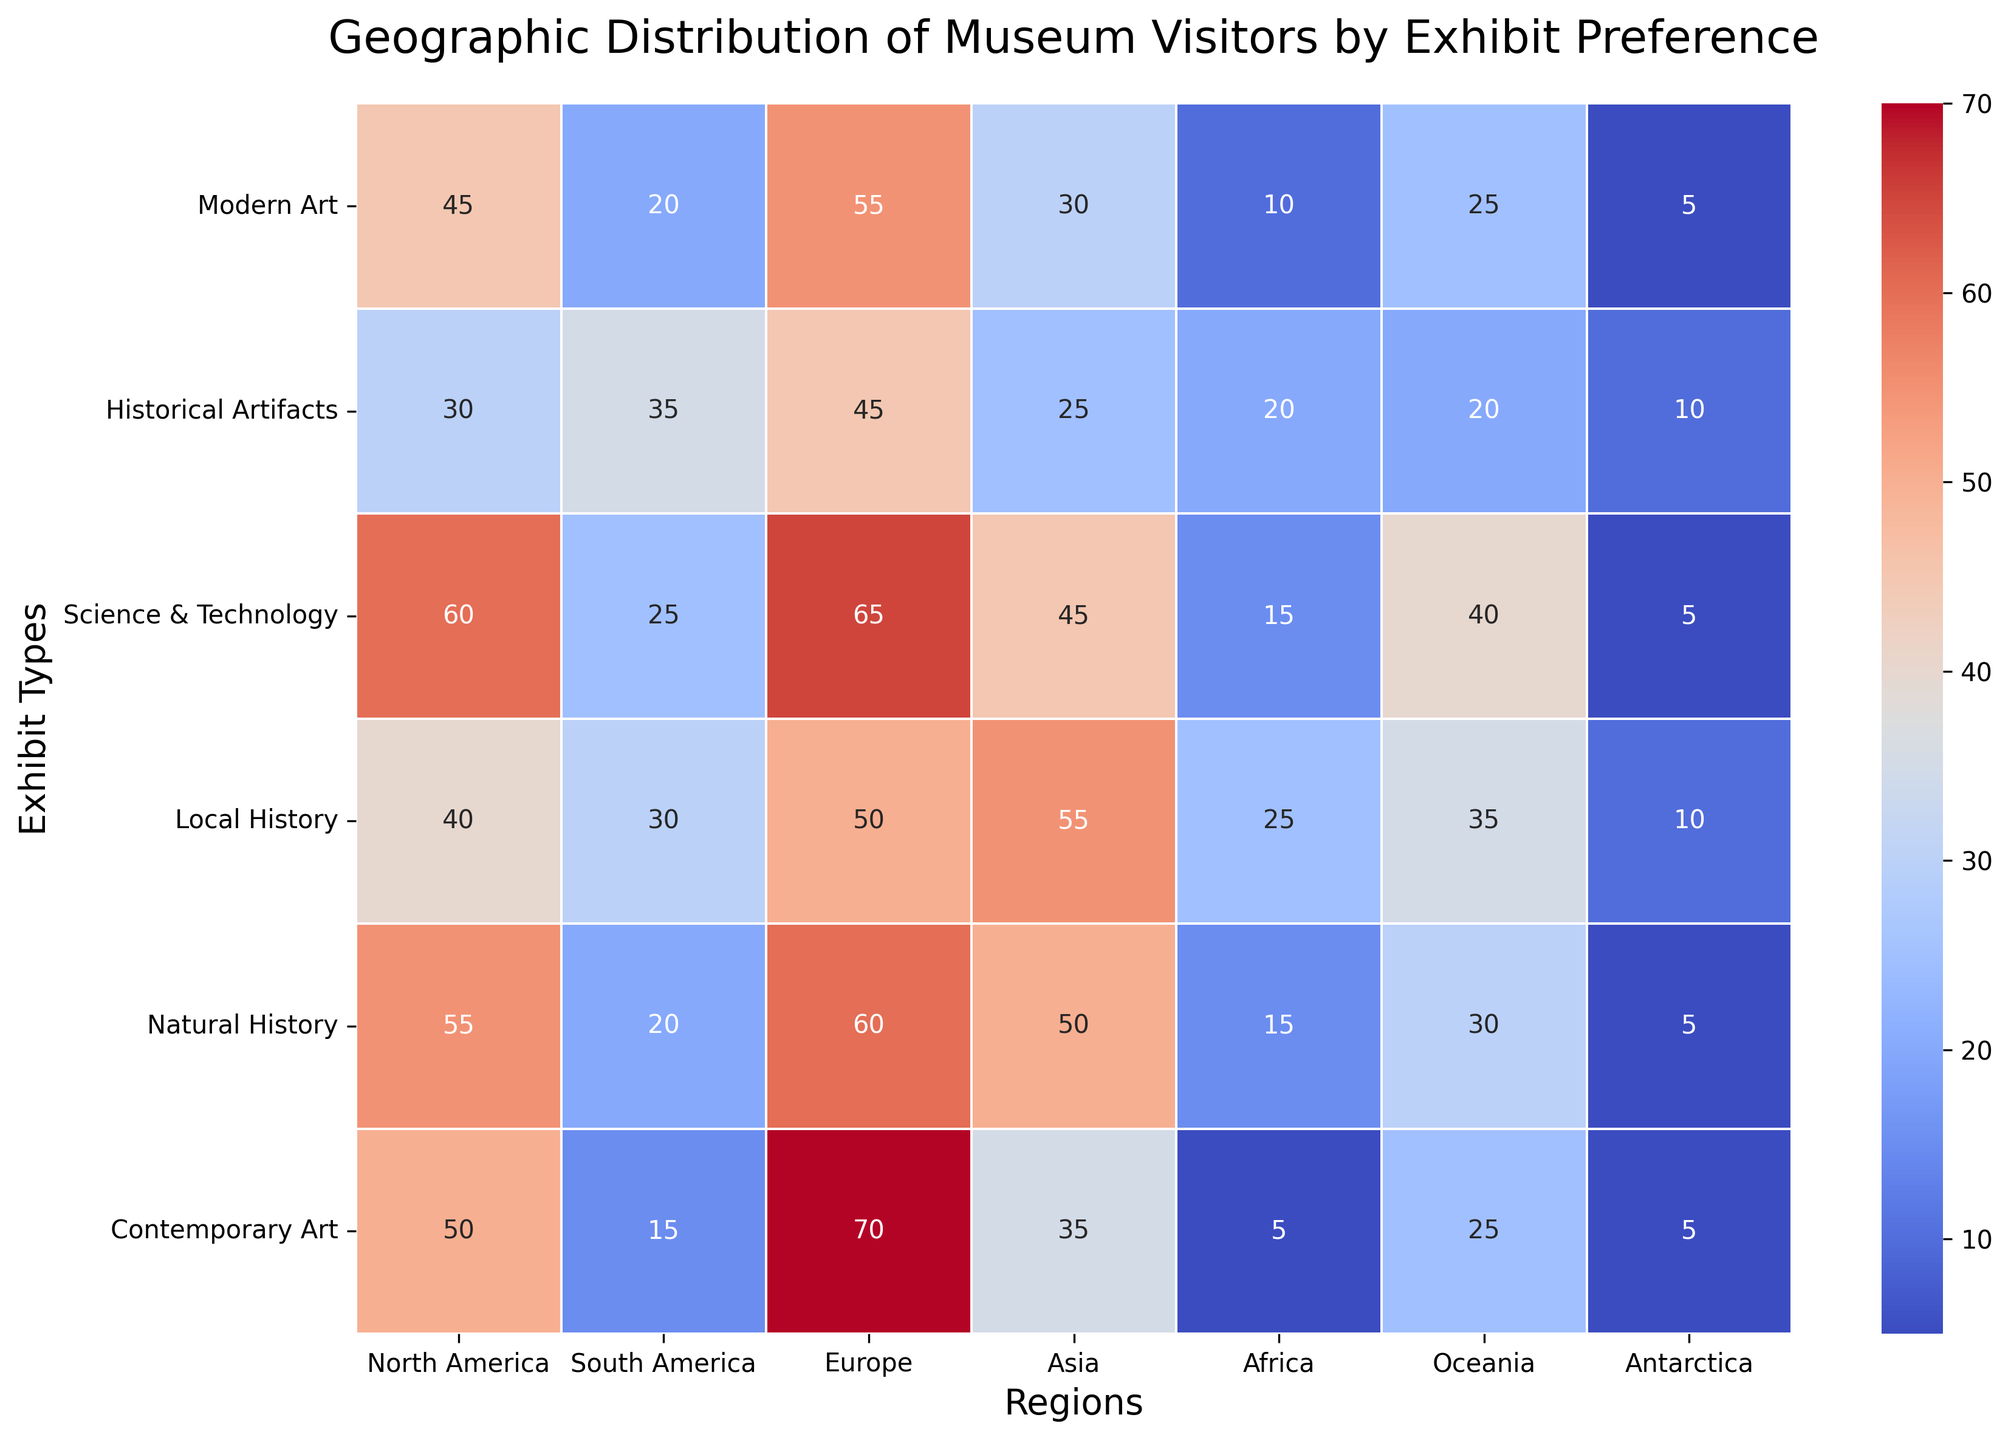What is the most preferred exhibit type in North America? To find the most preferred exhibit type in North America, look for the highest value in the "North America" column. The values are: Modern Art (45), Historical Artifacts (30), Science & Technology (60), Local History (40), Natural History (55), Contemporary Art (50). The highest value is 60 for Science & Technology.
Answer: Science & Technology Which region has the least preference for Contemporary Art? To determine which region has the least preference for Contemporary Art, look for the lowest value in the "Contemporary Art" row. The values are: North America (50), South America (15), Europe (70), Asia (35), Africa (5), Oceania (25), Antarctica (5). The lowest value is 5, found in both Africa and Antarctica.
Answer: Africa, Antarctica How many more visitors prefer Modern Art in Europe compared to Asia? First, identify the number of visitors preferring Modern Art in Europe and Asia. Europe has 55 visitors, and Asia has 30. The difference is 55 - 30 = 25.
Answer: 25 What is the average number of visitors for Natural History exhibits across all regions? To find the average, sum the values in the "Natural History" column and divide by the number of regions. The values are: North America (55), South America (20), Europe (60), Asia (50), Africa (15), Oceania (30), Antarctica (5). The sum is 55 + 20 + 60 + 50 + 15 + 30 + 5 = 235. There are 7 regions, so the average is 235 / 7 ≈ 33.57.
Answer: 33.57 Which exhibit type has the highest overall preference in Europe? To determine the exhibit type with the highest overall preference in Europe, identify the highest value in the "Europe" column. The values are: Modern Art (55), Historical Artifacts (45), Science & Technology (65), Local History (50), Natural History (60), Contemporary Art (70). The highest value is 70 for Contemporary Art.
Answer: Contemporary Art How does the preference for Science & Technology in South America compare with Asia? Compare the values for Science & Technology exhibits in South America and Asia. South America has 25 visitors, while Asia has 45. Thus, Asia has a higher preference for Science & Technology than South America.
Answer: Asia has more preference Which region has the highest combined preference for Historical Artifacts and Local History? Compute the sum of preferences for Historical Artifacts and Local History for each region and identify the highest. The sums are: North America (70), South America (65), Europe (95), Asia (80), Africa (45), Oceania (55), Antarctica (20). The highest combined preference is 95 in Europe.
Answer: Europe Which exhibit types have a higher than average preference in Asia? Determine the average preference for each exhibit type by summing the corresponding row values and dividing by 7. Compare each value in the "Asia" column to these averages. The values and calculations are:
- Modern Art: (45+20+55+30+10+25+5)/7 ≈ 27.14 (30 > 27.14)
- Historical Artifacts: (30+35+45+25+20+20+10)/7 ≈ 26.43 (25 < 26.43)
- Science & Technology: (60+25+65+45+15+40+5)/7 ≈ 36.43 (45 > 36.43)
- Local History: (40+30+50+55+25+35+10)/7 ≈ 35.00 (55 > 35.00)
- Natural History: (55+20+60+50+15+30+5)/7 ≈ 33.57 (50 > 33.57)
- Contemporary Art: (50+15+70+35+5+25+5)/7 ≈ 29.29 (35 > 29.29)
The exhibit types with higher than the average preference in Asia are Modern Art, Science & Technology, Local History, Natural History, Contemporary Art.
Answer: Modern Art, Science & Technology, Local History, Natural History, Contemporary Art 